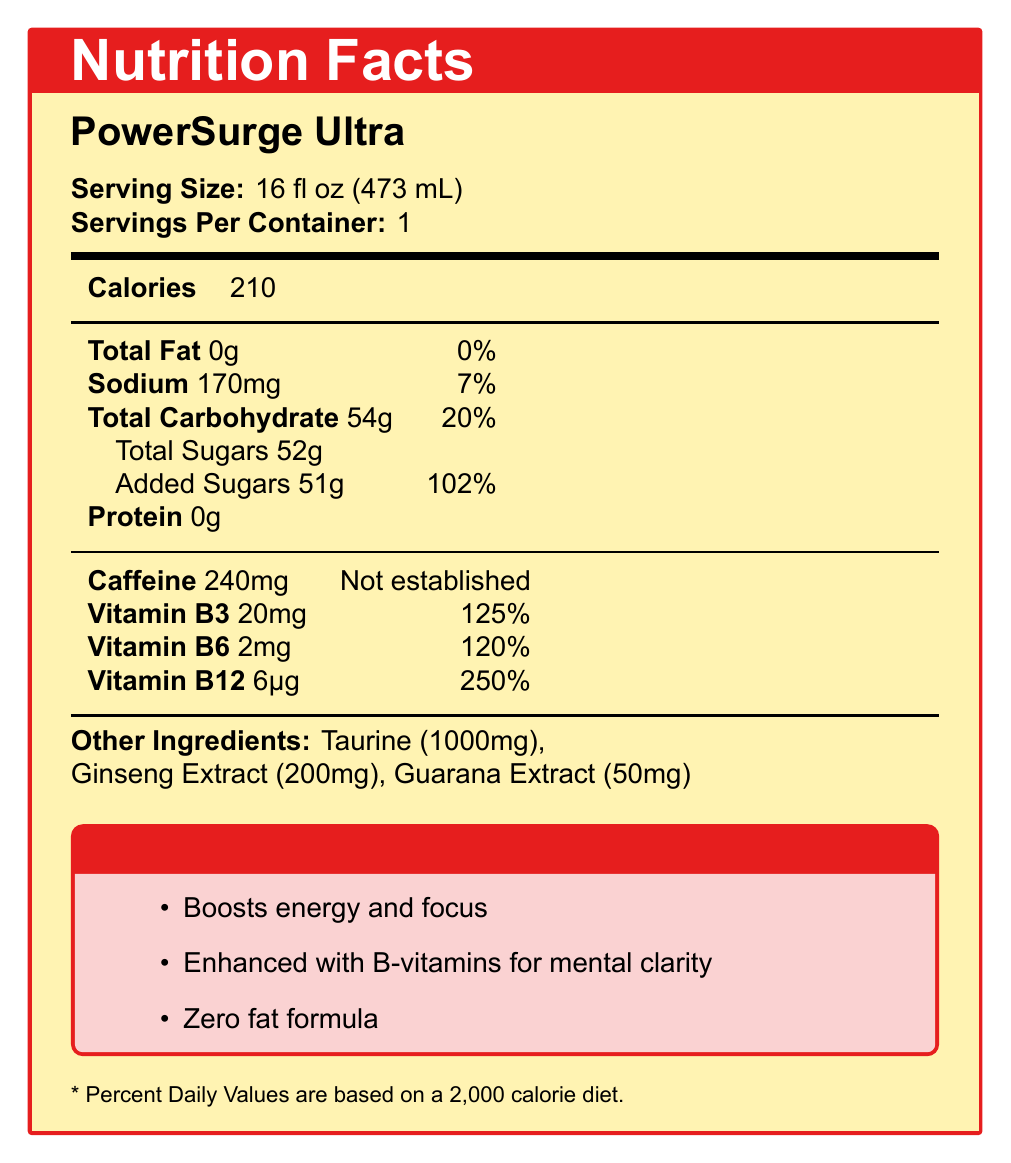what is the serving size? The serving size is stated at the beginning of the document as "Serving Size: 16 fl oz (473 mL)".
Answer: 16 fl oz (473 mL) how many calories are in one serving of PowerSurge Ultra? The document lists "Calories: 210" for one serving size.
Answer: 210 what is the amount of caffeine in PowerSurge Ultra? The document provides the caffeine amount as "Caffeine: 240mg".
Answer: 240mg how much added sugar is in one serving of PowerSurge Ultra? The document states "Added Sugars: 51g" under Total Carbohydrate.
Answer: 51g where should PowerSurge Ultra be placed to maximize impulse purchases? The sales strategy listed in the document suggests placing it near the checkout for impulse purchases.
Answer: Near checkout how many servings are in one container? The document states "Servings Per Container: 1".
Answer: 1 what claims does PowerSurge Ultra make about its benefits? The document lists these marketing claims under "PowerSurge Benefits".
Answer: Boosts energy and focus, Enhanced with B-vitamins for mental clarity, Zero fat formula what percent of the daily value of sodium does one serving of PowerSurge Ultra provide? The document states "Sodium: 170mg" with a daily value percentage of "7%".
Answer: 7% how much vitamin B12 is present in PowerSurge Ultra? The document lists "Vitamin B12: 6µg" with a daily value percentage of "250%".
Answer: 6µg which ingredient has the highest amount in PowerSurge Ultra? A. Taurine B. Ginseng Extract C. Guarana Extract D. Caffeine The document indicates that taurine has 1000mg, whereas ginseng extract and guarana extract have 200mg and 50mg, respectively. Caffeine is not considered here for this question as it is covered separately.
Answer: A. Taurine what is the profit margin for PowerSurge Ultra? A. 30% B. 42% C. 50% D. 60% The document mentions that the profit margin is "42%" under the marketing information.
Answer: B. 42% does PowerSurge Ultra contain any fats? The document states "Total Fat: 0g" with a daily value of "0%".
Answer: No summarize the main nutrients and benefits of PowerSurge Ultra in one sentence. The summary captures the key nutritional components and the asserted benefits stated in the document.
Answer: PowerSurge Ultra provides a high caffeine content (240mg), significant added sugars (51g), essential B-vitamins, and claims to boost energy and mental clarity without any fat. what is the wholesale price of PowerSurge Ultra? The document does not provide any specific information about the wholesale price in the visible sections.
Answer: Unknown how much total carbohydrate does one serving of PowerSurge Ultra contain? The document lists "Total Carbohydrate: 54g" with a "20%" daily value under nutritional information.
Answer: 54g what vitamins are enhanced in PowerSurge Ultra? The document lists the B-vitamins with their respective amounts: "Vitamin B3: 20mg", "Vitamin B6: 2mg", and "Vitamin B12: 6µg".
Answer: Vitamins B3, B6, and B12 is the daily value of caffeine intake established in PowerSurge Ultra? True/False The document states "Caffeine: 240mg" with "Not established" for the daily value.
Answer: False can you determine the number of employees working for the company producing PowerSurge Ultra based on the document? The document only provides nutritional and marketing information and does not discuss company staffing.
Answer: Not enough information 